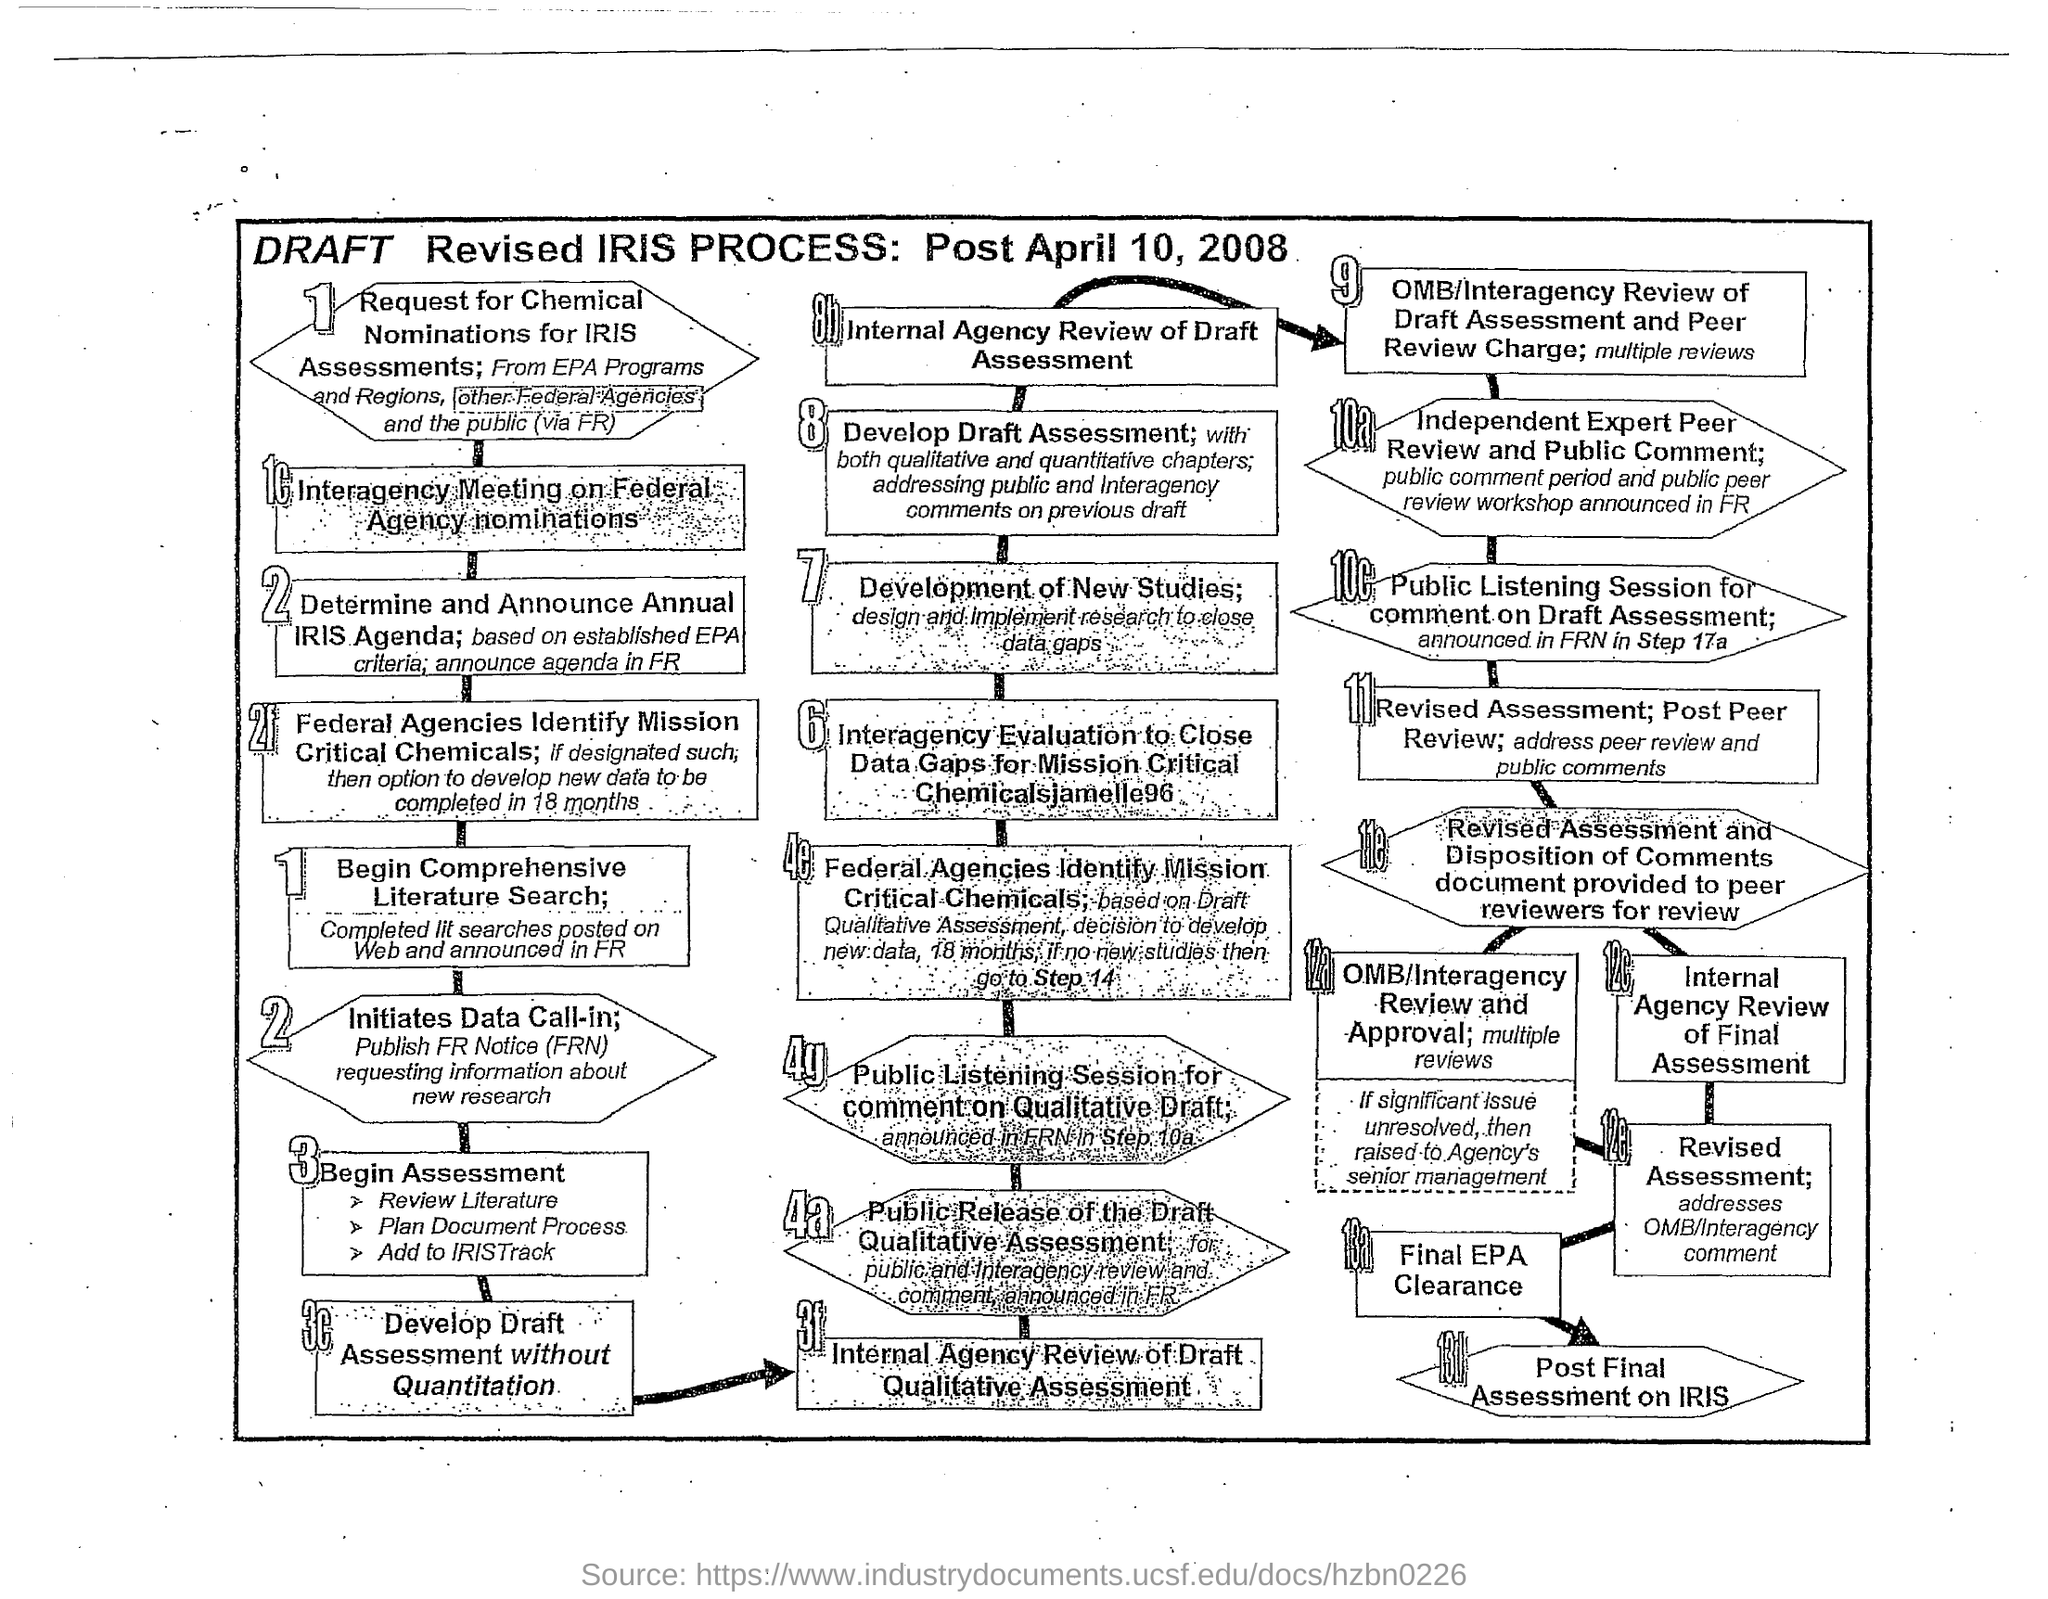Give some essential details in this illustration. The date mentioned is after April 10, 2008. The seventh step in the flowchart is the development of new studies, which involves designing and implementing research to close data gaps. 